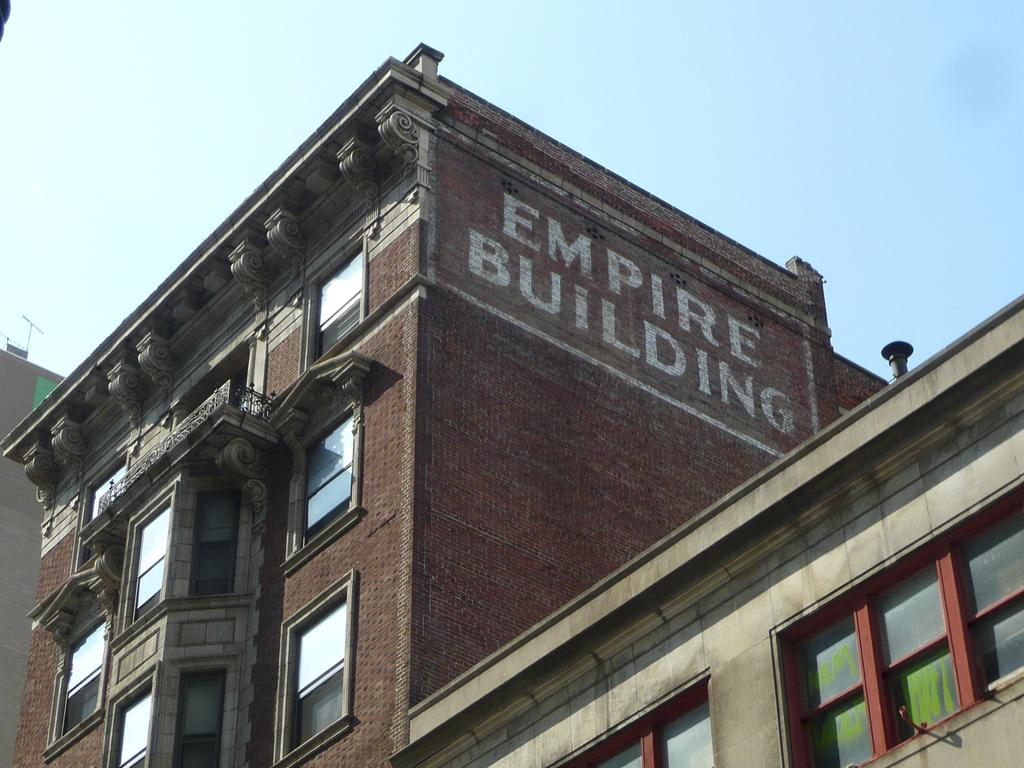What is written on the building in the image? There is text painted on a building in the image. What are some features of the building? The building has windows. What can be seen in the background of the image? There are other buildings in the background. What is visible at the top of the image? The sky is visible at the top of the image. How many dinosaurs are visible in the image? There are no dinosaurs present in the image. What type of light is being used to illuminate the text on the building? The image does not provide information about the type of light used to illuminate the text on the building. 